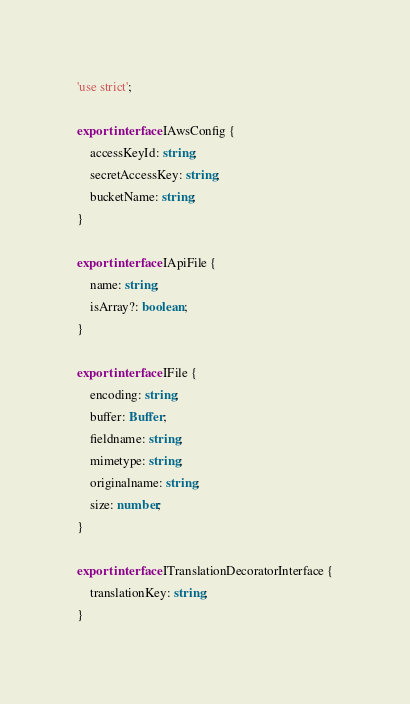Convert code to text. <code><loc_0><loc_0><loc_500><loc_500><_TypeScript_>'use strict';

export interface IAwsConfig {
    accessKeyId: string;
    secretAccessKey: string;
    bucketName: string;
}

export interface IApiFile {
    name: string;
    isArray?: boolean;
}

export interface IFile {
    encoding: string;
    buffer: Buffer;
    fieldname: string;
    mimetype: string;
    originalname: string;
    size: number;
}

export interface ITranslationDecoratorInterface {
    translationKey: string;
}
</code> 